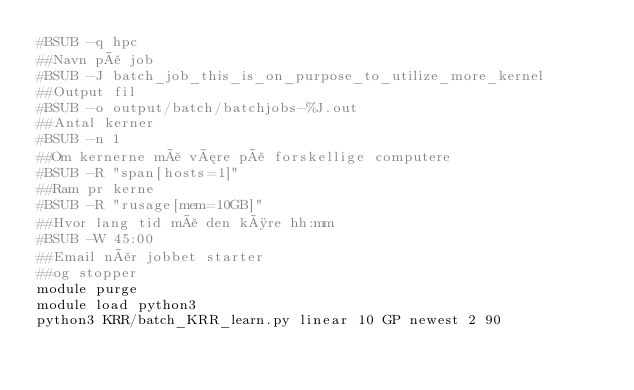<code> <loc_0><loc_0><loc_500><loc_500><_Bash_>#BSUB -q hpc
##Navn på job
#BSUB -J batch_job_this_is_on_purpose_to_utilize_more_kernel
##Output fil
#BSUB -o output/batch/batchjobs-%J.out
##Antal kerner
#BSUB -n 1
##Om kernerne må være på forskellige computere
#BSUB -R "span[hosts=1]"
##Ram pr kerne
#BSUB -R "rusage[mem=10GB]"
##Hvor lang tid må den køre hh:mm
#BSUB -W 45:00
##Email når jobbet starter
##og stopper
module purge
module load python3
python3 KRR/batch_KRR_learn.py linear 10 GP newest 2 90</code> 